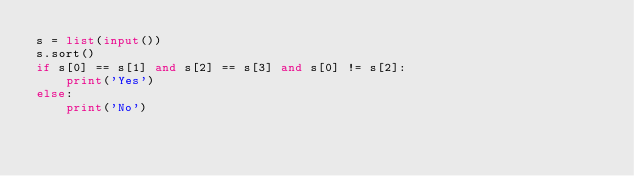Convert code to text. <code><loc_0><loc_0><loc_500><loc_500><_Python_>s = list(input())
s.sort()
if s[0] == s[1] and s[2] == s[3] and s[0] != s[2]:
    print('Yes')
else:
    print('No')
</code> 